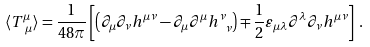<formula> <loc_0><loc_0><loc_500><loc_500>\langle T ^ { \mu } _ { \ \mu } \rangle = \frac { 1 } { 4 8 \pi } \left [ \left ( \partial _ { \mu } \partial _ { \nu } h ^ { \mu \nu } - \partial _ { \mu } \partial ^ { \mu } h ^ { \nu } _ { \ \nu } \right ) \mp \frac { 1 } { 2 } \varepsilon _ { \mu \lambda } \partial ^ { \lambda } \partial _ { \nu } h ^ { \mu \nu } \right ] \, .</formula> 